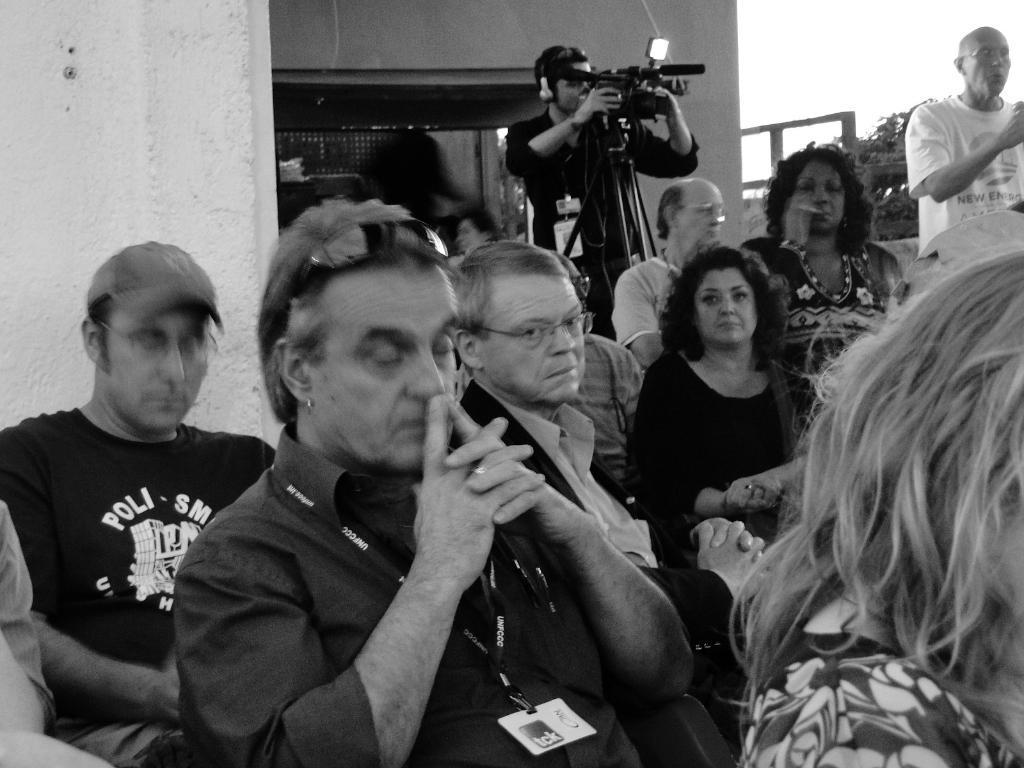How would you summarize this image in a sentence or two? Here in this picture we can see group of people sitting on chairs over there and we can see ID cards with some people and we can see goggles and caps with some people and behind them we can see a person holding a video camera in his hand with tripod below it and he is shooting the total program and in the far we can see trees present over there. 